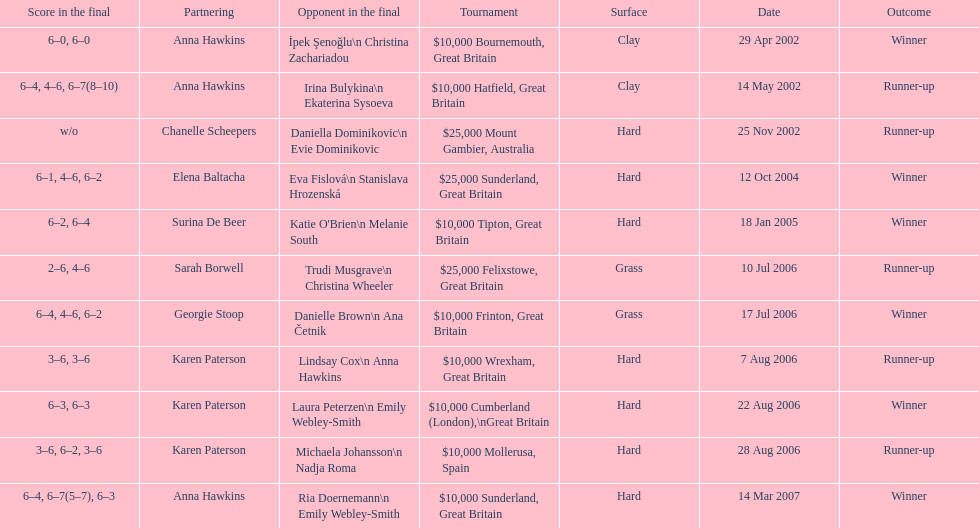What is the partnering name above chanelle scheepers? Anna Hawkins. 